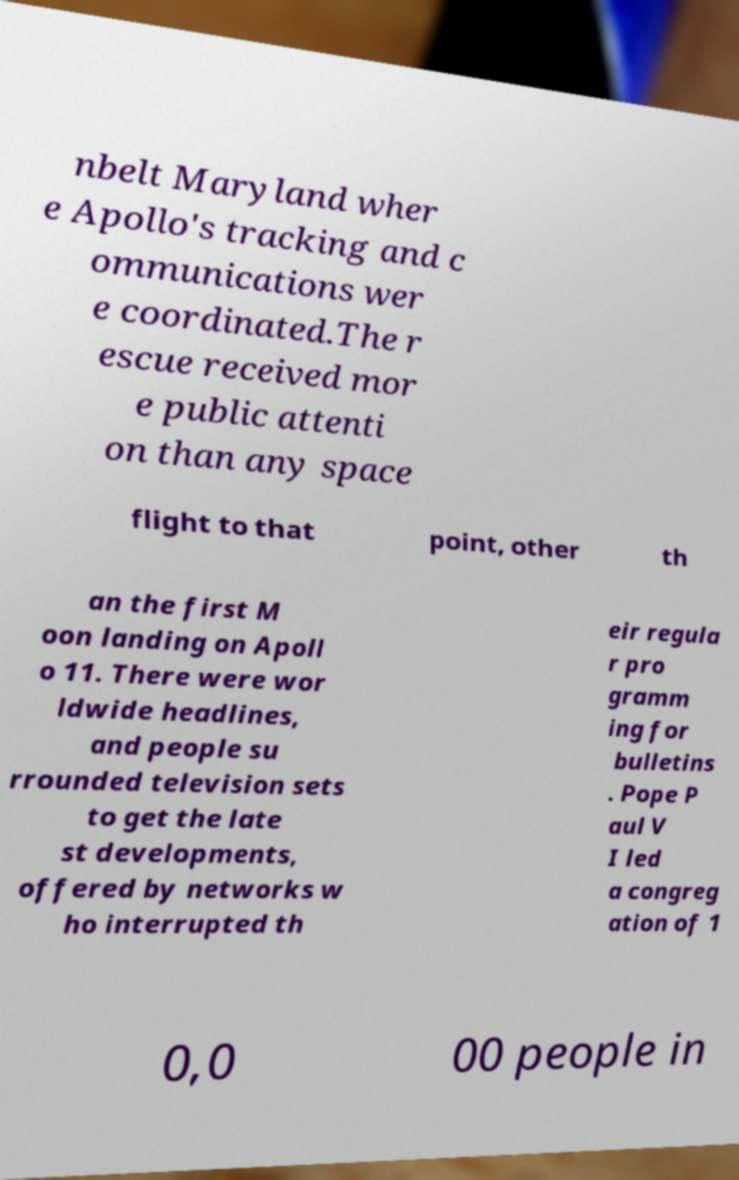Can you read and provide the text displayed in the image?This photo seems to have some interesting text. Can you extract and type it out for me? nbelt Maryland wher e Apollo's tracking and c ommunications wer e coordinated.The r escue received mor e public attenti on than any space flight to that point, other th an the first M oon landing on Apoll o 11. There were wor ldwide headlines, and people su rrounded television sets to get the late st developments, offered by networks w ho interrupted th eir regula r pro gramm ing for bulletins . Pope P aul V I led a congreg ation of 1 0,0 00 people in 